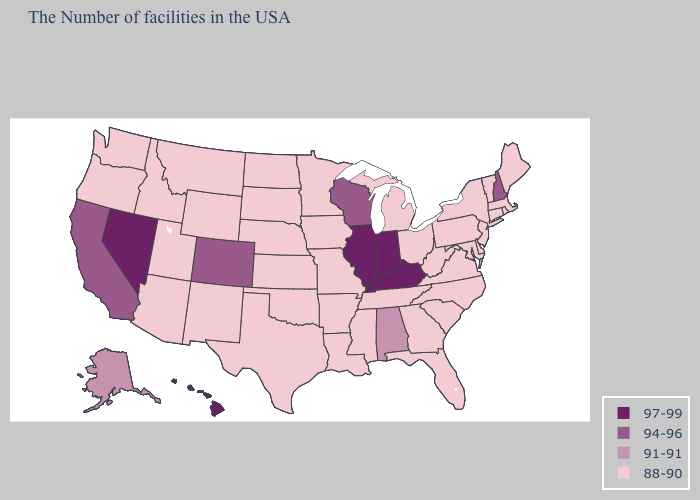Name the states that have a value in the range 88-90?
Write a very short answer. Maine, Massachusetts, Rhode Island, Vermont, Connecticut, New York, New Jersey, Delaware, Maryland, Pennsylvania, Virginia, North Carolina, South Carolina, West Virginia, Ohio, Florida, Georgia, Michigan, Tennessee, Mississippi, Louisiana, Missouri, Arkansas, Minnesota, Iowa, Kansas, Nebraska, Oklahoma, Texas, South Dakota, North Dakota, Wyoming, New Mexico, Utah, Montana, Arizona, Idaho, Washington, Oregon. Name the states that have a value in the range 91-91?
Write a very short answer. Alabama, Alaska. How many symbols are there in the legend?
Answer briefly. 4. Among the states that border Oregon , which have the highest value?
Quick response, please. Nevada. What is the highest value in the MidWest ?
Keep it brief. 97-99. What is the value of Colorado?
Answer briefly. 94-96. What is the lowest value in the Northeast?
Quick response, please. 88-90. What is the value of Kansas?
Answer briefly. 88-90. Among the states that border Nevada , which have the lowest value?
Short answer required. Utah, Arizona, Idaho, Oregon. Which states hav the highest value in the Northeast?
Answer briefly. New Hampshire. Name the states that have a value in the range 91-91?
Short answer required. Alabama, Alaska. Among the states that border Iowa , which have the highest value?
Keep it brief. Illinois. Among the states that border Virginia , which have the lowest value?
Answer briefly. Maryland, North Carolina, West Virginia, Tennessee. Is the legend a continuous bar?
Give a very brief answer. No. 